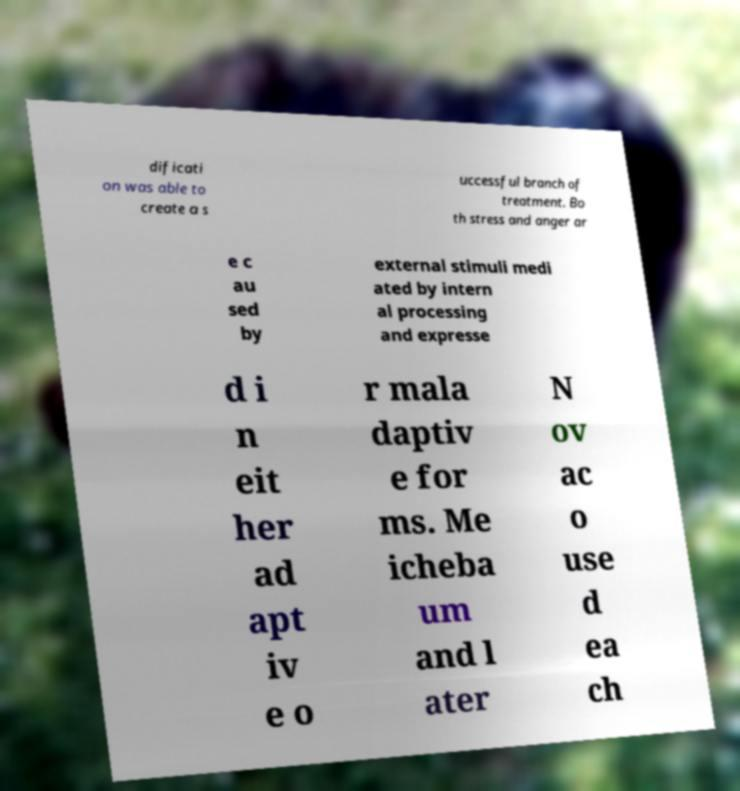What messages or text are displayed in this image? I need them in a readable, typed format. dificati on was able to create a s uccessful branch of treatment. Bo th stress and anger ar e c au sed by external stimuli medi ated by intern al processing and expresse d i n eit her ad apt iv e o r mala daptiv e for ms. Me icheba um and l ater N ov ac o use d ea ch 